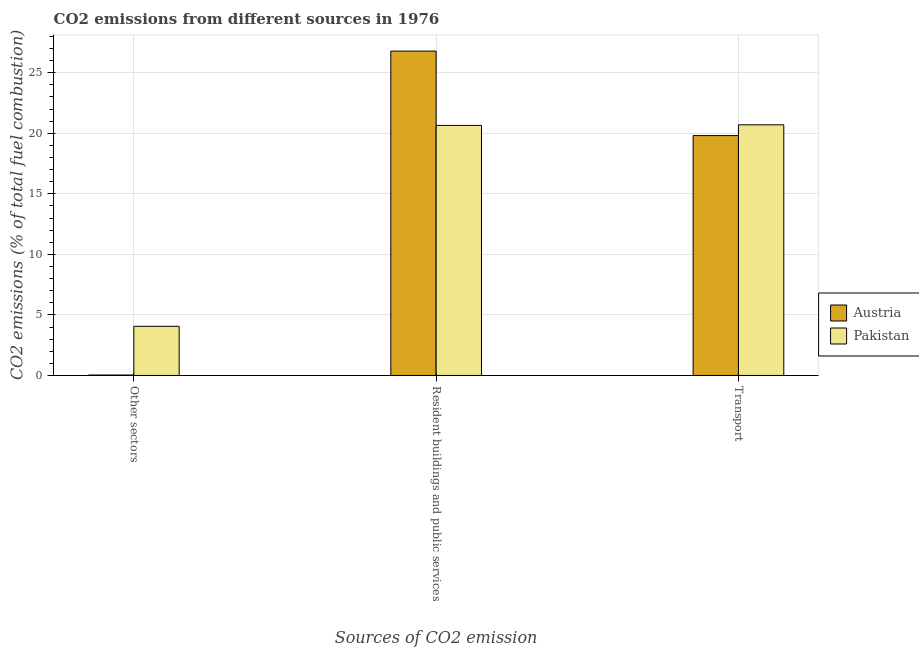Are the number of bars per tick equal to the number of legend labels?
Provide a short and direct response. Yes. Are the number of bars on each tick of the X-axis equal?
Provide a succinct answer. Yes. How many bars are there on the 3rd tick from the right?
Keep it short and to the point. 2. What is the label of the 2nd group of bars from the left?
Your response must be concise. Resident buildings and public services. What is the percentage of co2 emissions from other sectors in Pakistan?
Offer a terse response. 4.06. Across all countries, what is the maximum percentage of co2 emissions from other sectors?
Make the answer very short. 4.06. Across all countries, what is the minimum percentage of co2 emissions from transport?
Provide a short and direct response. 19.81. What is the total percentage of co2 emissions from other sectors in the graph?
Provide a short and direct response. 4.1. What is the difference between the percentage of co2 emissions from resident buildings and public services in Austria and that in Pakistan?
Provide a short and direct response. 6.14. What is the difference between the percentage of co2 emissions from other sectors in Pakistan and the percentage of co2 emissions from transport in Austria?
Make the answer very short. -15.75. What is the average percentage of co2 emissions from other sectors per country?
Your answer should be compact. 2.05. What is the difference between the percentage of co2 emissions from resident buildings and public services and percentage of co2 emissions from transport in Austria?
Give a very brief answer. 6.98. What is the ratio of the percentage of co2 emissions from other sectors in Austria to that in Pakistan?
Give a very brief answer. 0.01. Is the percentage of co2 emissions from other sectors in Pakistan less than that in Austria?
Give a very brief answer. No. Is the difference between the percentage of co2 emissions from other sectors in Pakistan and Austria greater than the difference between the percentage of co2 emissions from transport in Pakistan and Austria?
Your answer should be very brief. Yes. What is the difference between the highest and the second highest percentage of co2 emissions from transport?
Your answer should be compact. 0.89. What is the difference between the highest and the lowest percentage of co2 emissions from transport?
Your answer should be compact. 0.89. In how many countries, is the percentage of co2 emissions from resident buildings and public services greater than the average percentage of co2 emissions from resident buildings and public services taken over all countries?
Offer a very short reply. 1. Is the sum of the percentage of co2 emissions from resident buildings and public services in Pakistan and Austria greater than the maximum percentage of co2 emissions from other sectors across all countries?
Ensure brevity in your answer.  Yes. What does the 2nd bar from the left in Transport represents?
Offer a terse response. Pakistan. Is it the case that in every country, the sum of the percentage of co2 emissions from other sectors and percentage of co2 emissions from resident buildings and public services is greater than the percentage of co2 emissions from transport?
Provide a short and direct response. Yes. How many bars are there?
Provide a short and direct response. 6. Are the values on the major ticks of Y-axis written in scientific E-notation?
Give a very brief answer. No. Does the graph contain any zero values?
Your answer should be compact. No. How many legend labels are there?
Offer a terse response. 2. What is the title of the graph?
Ensure brevity in your answer.  CO2 emissions from different sources in 1976. What is the label or title of the X-axis?
Offer a very short reply. Sources of CO2 emission. What is the label or title of the Y-axis?
Your answer should be very brief. CO2 emissions (% of total fuel combustion). What is the CO2 emissions (% of total fuel combustion) of Austria in Other sectors?
Keep it short and to the point. 0.04. What is the CO2 emissions (% of total fuel combustion) of Pakistan in Other sectors?
Offer a terse response. 4.06. What is the CO2 emissions (% of total fuel combustion) in Austria in Resident buildings and public services?
Offer a terse response. 26.79. What is the CO2 emissions (% of total fuel combustion) in Pakistan in Resident buildings and public services?
Your response must be concise. 20.65. What is the CO2 emissions (% of total fuel combustion) of Austria in Transport?
Your answer should be compact. 19.81. What is the CO2 emissions (% of total fuel combustion) of Pakistan in Transport?
Your answer should be very brief. 20.7. Across all Sources of CO2 emission, what is the maximum CO2 emissions (% of total fuel combustion) of Austria?
Offer a very short reply. 26.79. Across all Sources of CO2 emission, what is the maximum CO2 emissions (% of total fuel combustion) of Pakistan?
Your answer should be very brief. 20.7. Across all Sources of CO2 emission, what is the minimum CO2 emissions (% of total fuel combustion) in Austria?
Offer a terse response. 0.04. Across all Sources of CO2 emission, what is the minimum CO2 emissions (% of total fuel combustion) in Pakistan?
Give a very brief answer. 4.06. What is the total CO2 emissions (% of total fuel combustion) of Austria in the graph?
Offer a terse response. 46.64. What is the total CO2 emissions (% of total fuel combustion) in Pakistan in the graph?
Provide a short and direct response. 45.41. What is the difference between the CO2 emissions (% of total fuel combustion) of Austria in Other sectors and that in Resident buildings and public services?
Your response must be concise. -26.75. What is the difference between the CO2 emissions (% of total fuel combustion) in Pakistan in Other sectors and that in Resident buildings and public services?
Provide a short and direct response. -16.59. What is the difference between the CO2 emissions (% of total fuel combustion) in Austria in Other sectors and that in Transport?
Your answer should be very brief. -19.78. What is the difference between the CO2 emissions (% of total fuel combustion) of Pakistan in Other sectors and that in Transport?
Give a very brief answer. -16.64. What is the difference between the CO2 emissions (% of total fuel combustion) of Austria in Resident buildings and public services and that in Transport?
Offer a very short reply. 6.98. What is the difference between the CO2 emissions (% of total fuel combustion) of Pakistan in Resident buildings and public services and that in Transport?
Offer a very short reply. -0.05. What is the difference between the CO2 emissions (% of total fuel combustion) of Austria in Other sectors and the CO2 emissions (% of total fuel combustion) of Pakistan in Resident buildings and public services?
Keep it short and to the point. -20.61. What is the difference between the CO2 emissions (% of total fuel combustion) of Austria in Other sectors and the CO2 emissions (% of total fuel combustion) of Pakistan in Transport?
Your response must be concise. -20.66. What is the difference between the CO2 emissions (% of total fuel combustion) of Austria in Resident buildings and public services and the CO2 emissions (% of total fuel combustion) of Pakistan in Transport?
Keep it short and to the point. 6.09. What is the average CO2 emissions (% of total fuel combustion) of Austria per Sources of CO2 emission?
Provide a succinct answer. 15.55. What is the average CO2 emissions (% of total fuel combustion) in Pakistan per Sources of CO2 emission?
Offer a very short reply. 15.14. What is the difference between the CO2 emissions (% of total fuel combustion) in Austria and CO2 emissions (% of total fuel combustion) in Pakistan in Other sectors?
Ensure brevity in your answer.  -4.02. What is the difference between the CO2 emissions (% of total fuel combustion) of Austria and CO2 emissions (% of total fuel combustion) of Pakistan in Resident buildings and public services?
Give a very brief answer. 6.14. What is the difference between the CO2 emissions (% of total fuel combustion) of Austria and CO2 emissions (% of total fuel combustion) of Pakistan in Transport?
Offer a very short reply. -0.89. What is the ratio of the CO2 emissions (% of total fuel combustion) of Austria in Other sectors to that in Resident buildings and public services?
Your answer should be very brief. 0. What is the ratio of the CO2 emissions (% of total fuel combustion) in Pakistan in Other sectors to that in Resident buildings and public services?
Offer a very short reply. 0.2. What is the ratio of the CO2 emissions (% of total fuel combustion) of Austria in Other sectors to that in Transport?
Provide a short and direct response. 0. What is the ratio of the CO2 emissions (% of total fuel combustion) of Pakistan in Other sectors to that in Transport?
Offer a very short reply. 0.2. What is the ratio of the CO2 emissions (% of total fuel combustion) of Austria in Resident buildings and public services to that in Transport?
Offer a very short reply. 1.35. What is the difference between the highest and the second highest CO2 emissions (% of total fuel combustion) in Austria?
Keep it short and to the point. 6.98. What is the difference between the highest and the second highest CO2 emissions (% of total fuel combustion) of Pakistan?
Your answer should be very brief. 0.05. What is the difference between the highest and the lowest CO2 emissions (% of total fuel combustion) in Austria?
Give a very brief answer. 26.75. What is the difference between the highest and the lowest CO2 emissions (% of total fuel combustion) of Pakistan?
Offer a very short reply. 16.64. 